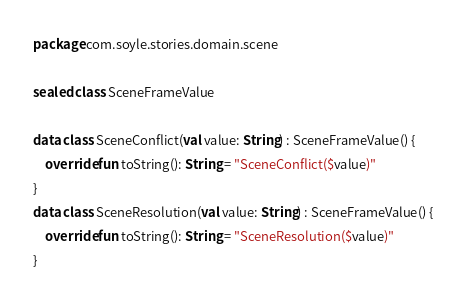<code> <loc_0><loc_0><loc_500><loc_500><_Kotlin_>package com.soyle.stories.domain.scene

sealed class SceneFrameValue

data class SceneConflict(val value: String) : SceneFrameValue() {
    override fun toString(): String = "SceneConflict($value)"
}
data class SceneResolution(val value: String) : SceneFrameValue() {
    override fun toString(): String = "SceneResolution($value)"
}</code> 